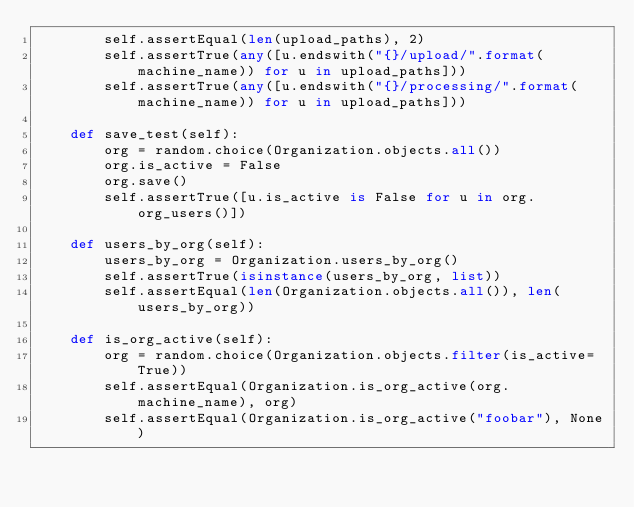Convert code to text. <code><loc_0><loc_0><loc_500><loc_500><_Python_>        self.assertEqual(len(upload_paths), 2)
        self.assertTrue(any([u.endswith("{}/upload/".format(machine_name)) for u in upload_paths]))
        self.assertTrue(any([u.endswith("{}/processing/".format(machine_name)) for u in upload_paths]))

    def save_test(self):
        org = random.choice(Organization.objects.all())
        org.is_active = False
        org.save()
        self.assertTrue([u.is_active is False for u in org.org_users()])

    def users_by_org(self):
        users_by_org = Organization.users_by_org()
        self.assertTrue(isinstance(users_by_org, list))
        self.assertEqual(len(Organization.objects.all()), len(users_by_org))

    def is_org_active(self):
        org = random.choice(Organization.objects.filter(is_active=True))
        self.assertEqual(Organization.is_org_active(org.machine_name), org)
        self.assertEqual(Organization.is_org_active("foobar"), None)
</code> 